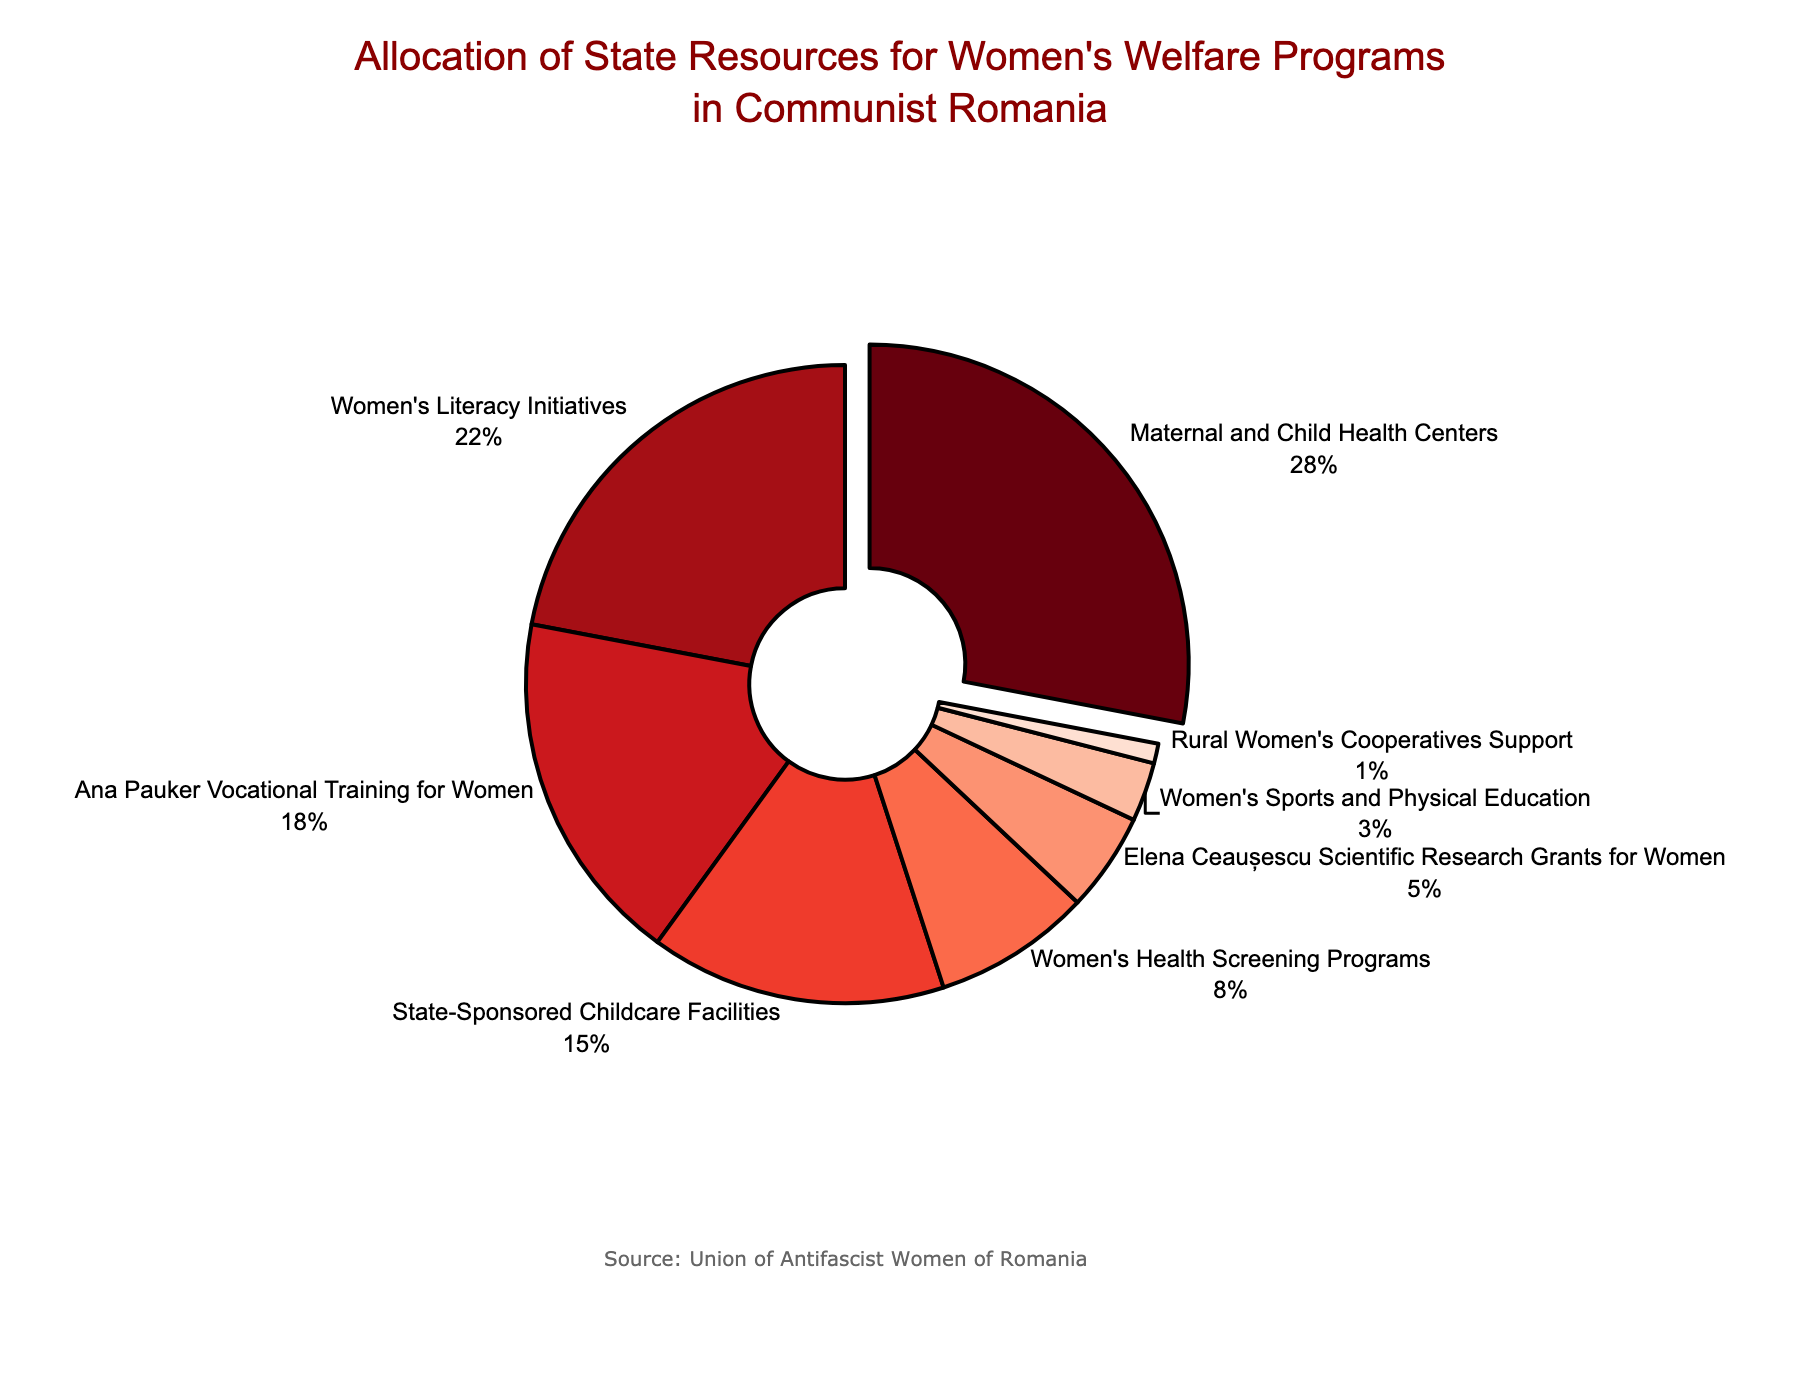Which program received the largest allocation of state resources? Maternal and Child Health Centers received the largest allocation of state resources as indicated by both the text and the largest portion of the pie chart.
Answer: Maternal and Child Health Centers What percentage of state resources was allocated to Women's Literacy Initiatives and State-Sponsored Childcare Facilities combined? Adding the allocation percentages: 22% (Women's Literacy Initiatives) + 15% (State-Sponsored Childcare Facilities) = 37%.
Answer: 37% Which program has a lower allocation of state resources: Women's Health Screening Programs or "Ana Pauker" Vocational Training for Women? Women's Health Screening Programs have a lower allocation (8%) compared to "Ana Pauker" Vocational Training for Women (18%) as seen directly from the pie chart values.
Answer: Women's Health Screening Programs By what percentage do resources allocated to "Ana Pauker" Vocational Training for Women exceed those for Women's Sports and Physical Education? The difference in allocation is 18% (Vocational Training) - 3% (Sports and PE) = 15%.
Answer: 15% Which programs have an allocation of state resources that is less than 10% each? The programs with less than 10% allocation are Women's Health Screening Programs (8%), "Elena Ceaușescu" Scientific Research Grants for Women (5%), Women's Sports and Physical Education (3%), and Rural Women's Cooperatives Support (1%) as indicated on the pie chart.
Answer: Women's Health Screening Programs, "Elena Ceaușescu" Scientific Research Grants for Women, Women's Sports and Physical Education, Rural Women's Cooperatives Support How does the allocation for Maternal and Child Health Centers compare to the combined allocation for Women's Health Screening Programs and "Elena Ceaușescu" Scientific Research Grants for Women? The allocation for Maternal and Child Health Centers is 28%. The combined allocation for Women's Health Screening Programs (8%) and "Elena Ceaușescu" Scientific Research Grants for Women (5%) is 13%. Therefore, Maternal and Child Health Centers receive 28% - 13% = 15% more.
Answer: 15% more What is the visual distinction between the program with the highest allocation and the others on the pie chart? The segment representing Maternal and Child Health Centers is slightly pulled out from the rest of the pie chart segments, and it is also the largest segment.
Answer: Pulled out and largest segment What portion of the chart represents programs specifically aimed at women's education and research? Adding the percentages for Women's Literacy Initiatives (22%) and "Elena Ceaușecu" Scientific Research Grants for Women (5%) indicates a combined portion of 27%.
Answer: 27% Which programs have very small allocations, each represented by narrow slices on the pie chart? Women's Sports and Physical Education (3%) and Rural Women's Cooperatives Support (1%) are represented by the narrowest slices on the pie chart, indicating very small allocations.
Answer: Women's Sports and Physical Education, Rural Women's Cooperatives Support 